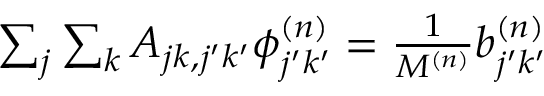<formula> <loc_0><loc_0><loc_500><loc_500>\begin{array} { r } { \sum _ { j } \sum _ { k } A _ { j k , j ^ { \prime } k ^ { \prime } } \phi _ { j ^ { \prime } k ^ { \prime } } ^ { ( n ) } = \frac { 1 } { M ^ { ( n ) } } b _ { j ^ { \prime } k ^ { \prime } } ^ { ( n ) } } \end{array}</formula> 